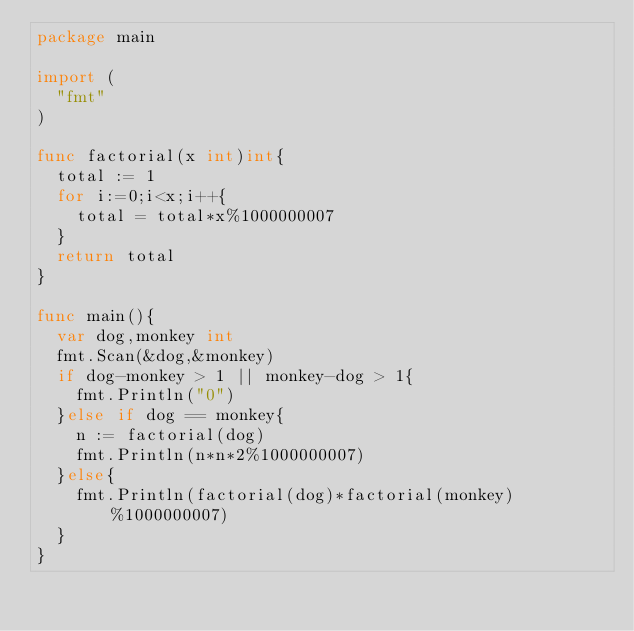<code> <loc_0><loc_0><loc_500><loc_500><_Go_>package main

import (
	"fmt"
)

func factorial(x int)int{
	total := 1
	for i:=0;i<x;i++{
		total = total*x%1000000007
	}
	return total
}

func main(){
	var dog,monkey int
	fmt.Scan(&dog,&monkey)
	if dog-monkey > 1 || monkey-dog > 1{
		fmt.Println("0")
	}else if dog == monkey{
		n := factorial(dog)
		fmt.Println(n*n*2%1000000007)
	}else{
		fmt.Println(factorial(dog)*factorial(monkey)%1000000007)
	}
}</code> 